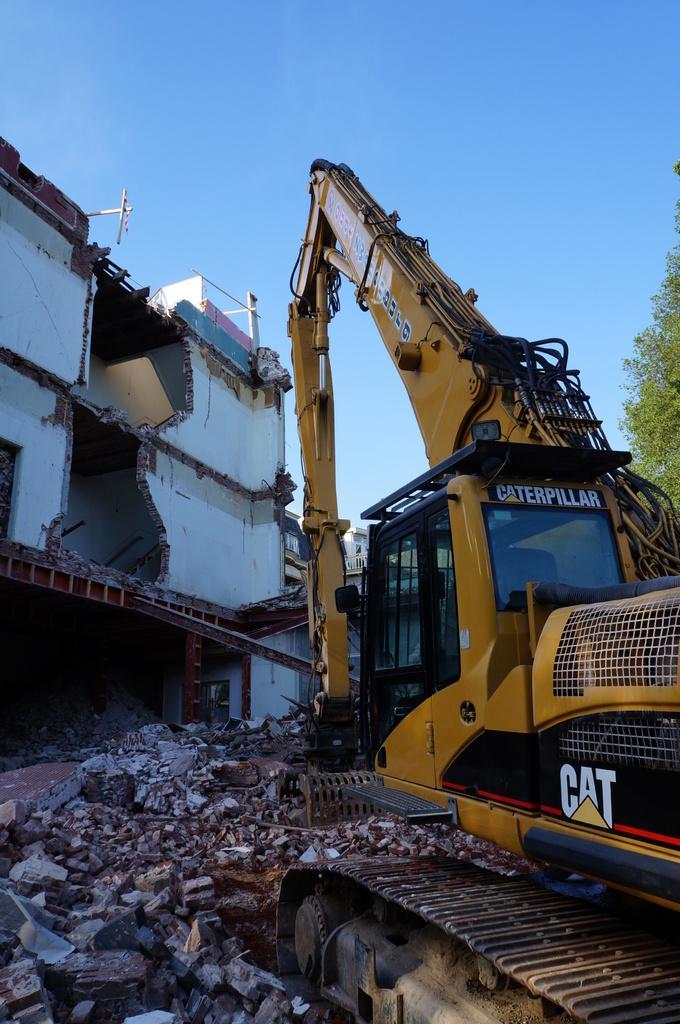Could you give a brief overview of what you see in this image? This picture is clicked outside. On the right crane and we can see the bricks and stones lying on the ground and we can see the house which is partially collapsed. In the background there is a sky and we can see the tree and some buildings. 